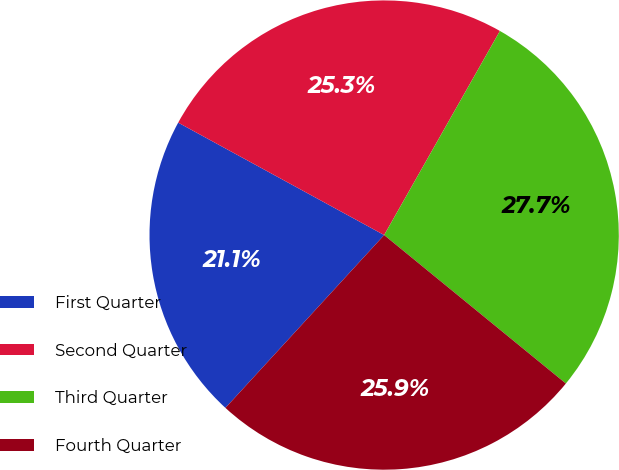Convert chart to OTSL. <chart><loc_0><loc_0><loc_500><loc_500><pie_chart><fcel>First Quarter<fcel>Second Quarter<fcel>Third Quarter<fcel>Fourth Quarter<nl><fcel>21.13%<fcel>25.26%<fcel>27.69%<fcel>25.92%<nl></chart> 